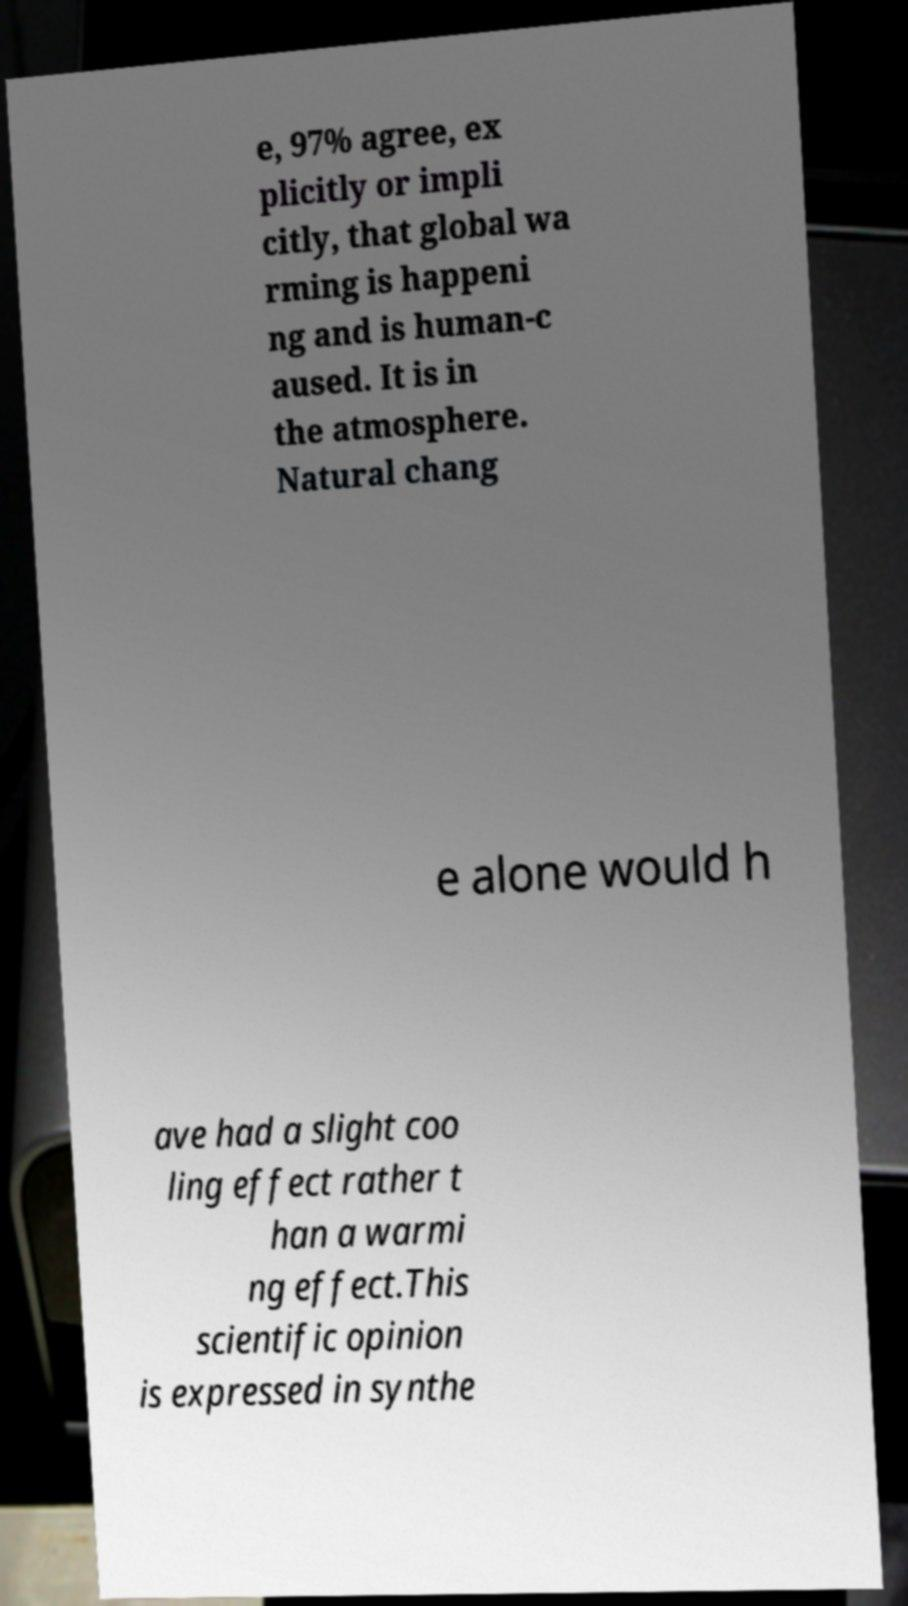What messages or text are displayed in this image? I need them in a readable, typed format. e, 97% agree, ex plicitly or impli citly, that global wa rming is happeni ng and is human-c aused. It is in the atmosphere. Natural chang e alone would h ave had a slight coo ling effect rather t han a warmi ng effect.This scientific opinion is expressed in synthe 